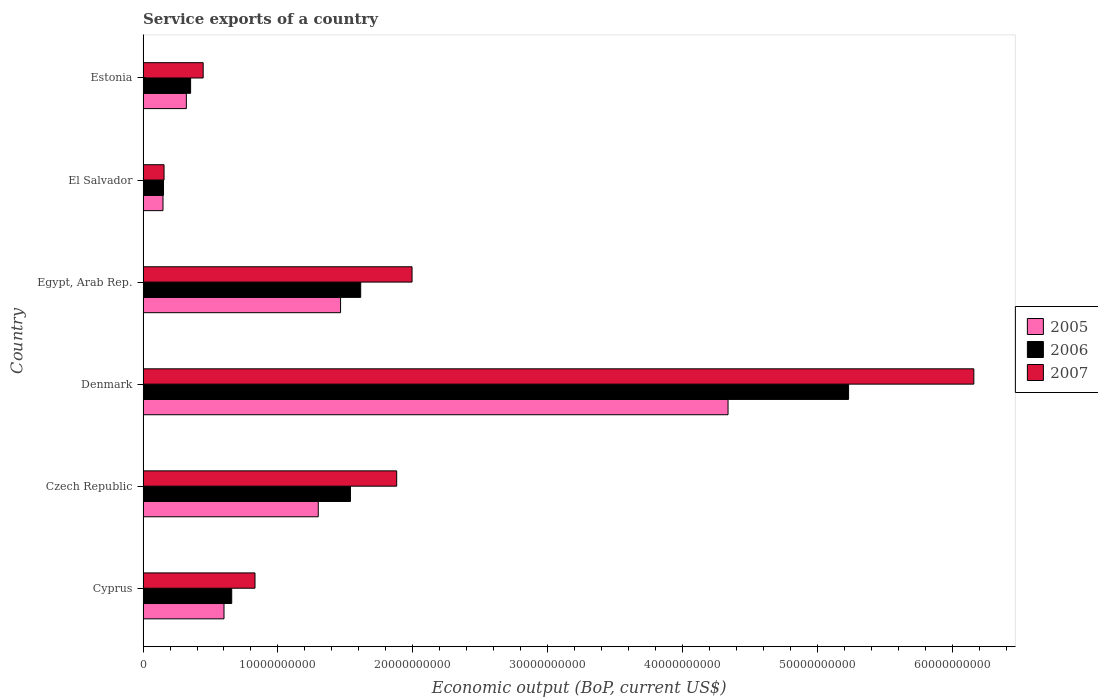Are the number of bars per tick equal to the number of legend labels?
Provide a succinct answer. Yes. Are the number of bars on each tick of the Y-axis equal?
Ensure brevity in your answer.  Yes. How many bars are there on the 5th tick from the top?
Offer a terse response. 3. In how many cases, is the number of bars for a given country not equal to the number of legend labels?
Give a very brief answer. 0. What is the service exports in 2006 in Czech Republic?
Your response must be concise. 1.54e+1. Across all countries, what is the maximum service exports in 2007?
Ensure brevity in your answer.  6.16e+1. Across all countries, what is the minimum service exports in 2005?
Your answer should be compact. 1.48e+09. In which country was the service exports in 2007 minimum?
Your response must be concise. El Salvador. What is the total service exports in 2006 in the graph?
Give a very brief answer. 9.54e+1. What is the difference between the service exports in 2007 in Czech Republic and that in El Salvador?
Your answer should be very brief. 1.72e+1. What is the difference between the service exports in 2007 in El Salvador and the service exports in 2006 in Czech Republic?
Provide a succinct answer. -1.38e+1. What is the average service exports in 2005 per country?
Give a very brief answer. 1.36e+1. What is the difference between the service exports in 2006 and service exports in 2007 in El Salvador?
Give a very brief answer. -3.97e+07. In how many countries, is the service exports in 2006 greater than 10000000000 US$?
Make the answer very short. 3. What is the ratio of the service exports in 2006 in Czech Republic to that in El Salvador?
Provide a succinct answer. 10.14. Is the service exports in 2007 in Cyprus less than that in Czech Republic?
Provide a short and direct response. Yes. Is the difference between the service exports in 2006 in Egypt, Arab Rep. and El Salvador greater than the difference between the service exports in 2007 in Egypt, Arab Rep. and El Salvador?
Provide a succinct answer. No. What is the difference between the highest and the second highest service exports in 2006?
Offer a very short reply. 3.62e+1. What is the difference between the highest and the lowest service exports in 2006?
Ensure brevity in your answer.  5.08e+1. In how many countries, is the service exports in 2005 greater than the average service exports in 2005 taken over all countries?
Your response must be concise. 2. Is the sum of the service exports in 2007 in Egypt, Arab Rep. and Estonia greater than the maximum service exports in 2005 across all countries?
Provide a succinct answer. No. What does the 3rd bar from the bottom in Denmark represents?
Offer a very short reply. 2007. Are all the bars in the graph horizontal?
Give a very brief answer. Yes. How many countries are there in the graph?
Offer a terse response. 6. Are the values on the major ticks of X-axis written in scientific E-notation?
Keep it short and to the point. No. Does the graph contain any zero values?
Provide a succinct answer. No. Does the graph contain grids?
Offer a terse response. No. How are the legend labels stacked?
Give a very brief answer. Vertical. What is the title of the graph?
Make the answer very short. Service exports of a country. Does "1998" appear as one of the legend labels in the graph?
Give a very brief answer. No. What is the label or title of the X-axis?
Your response must be concise. Economic output (BoP, current US$). What is the label or title of the Y-axis?
Your answer should be very brief. Country. What is the Economic output (BoP, current US$) of 2005 in Cyprus?
Ensure brevity in your answer.  6.00e+09. What is the Economic output (BoP, current US$) in 2006 in Cyprus?
Provide a short and direct response. 6.57e+09. What is the Economic output (BoP, current US$) of 2007 in Cyprus?
Provide a short and direct response. 8.30e+09. What is the Economic output (BoP, current US$) of 2005 in Czech Republic?
Keep it short and to the point. 1.30e+1. What is the Economic output (BoP, current US$) in 2006 in Czech Republic?
Your response must be concise. 1.54e+1. What is the Economic output (BoP, current US$) in 2007 in Czech Republic?
Your answer should be compact. 1.88e+1. What is the Economic output (BoP, current US$) of 2005 in Denmark?
Provide a succinct answer. 4.34e+1. What is the Economic output (BoP, current US$) of 2006 in Denmark?
Give a very brief answer. 5.23e+1. What is the Economic output (BoP, current US$) of 2007 in Denmark?
Your response must be concise. 6.16e+1. What is the Economic output (BoP, current US$) of 2005 in Egypt, Arab Rep.?
Offer a very short reply. 1.46e+1. What is the Economic output (BoP, current US$) in 2006 in Egypt, Arab Rep.?
Make the answer very short. 1.61e+1. What is the Economic output (BoP, current US$) in 2007 in Egypt, Arab Rep.?
Offer a very short reply. 1.99e+1. What is the Economic output (BoP, current US$) of 2005 in El Salvador?
Ensure brevity in your answer.  1.48e+09. What is the Economic output (BoP, current US$) of 2006 in El Salvador?
Make the answer very short. 1.52e+09. What is the Economic output (BoP, current US$) in 2007 in El Salvador?
Provide a short and direct response. 1.56e+09. What is the Economic output (BoP, current US$) in 2005 in Estonia?
Make the answer very short. 3.21e+09. What is the Economic output (BoP, current US$) of 2006 in Estonia?
Keep it short and to the point. 3.52e+09. What is the Economic output (BoP, current US$) in 2007 in Estonia?
Offer a terse response. 4.46e+09. Across all countries, what is the maximum Economic output (BoP, current US$) of 2005?
Offer a terse response. 4.34e+1. Across all countries, what is the maximum Economic output (BoP, current US$) of 2006?
Give a very brief answer. 5.23e+1. Across all countries, what is the maximum Economic output (BoP, current US$) of 2007?
Provide a short and direct response. 6.16e+1. Across all countries, what is the minimum Economic output (BoP, current US$) in 2005?
Make the answer very short. 1.48e+09. Across all countries, what is the minimum Economic output (BoP, current US$) of 2006?
Ensure brevity in your answer.  1.52e+09. Across all countries, what is the minimum Economic output (BoP, current US$) in 2007?
Your response must be concise. 1.56e+09. What is the total Economic output (BoP, current US$) of 2005 in the graph?
Your answer should be very brief. 8.17e+1. What is the total Economic output (BoP, current US$) of 2006 in the graph?
Provide a succinct answer. 9.54e+1. What is the total Economic output (BoP, current US$) of 2007 in the graph?
Your answer should be very brief. 1.15e+11. What is the difference between the Economic output (BoP, current US$) in 2005 in Cyprus and that in Czech Republic?
Your answer should be very brief. -6.99e+09. What is the difference between the Economic output (BoP, current US$) of 2006 in Cyprus and that in Czech Republic?
Make the answer very short. -8.80e+09. What is the difference between the Economic output (BoP, current US$) in 2007 in Cyprus and that in Czech Republic?
Provide a succinct answer. -1.05e+1. What is the difference between the Economic output (BoP, current US$) of 2005 in Cyprus and that in Denmark?
Give a very brief answer. -3.74e+1. What is the difference between the Economic output (BoP, current US$) of 2006 in Cyprus and that in Denmark?
Provide a short and direct response. -4.57e+1. What is the difference between the Economic output (BoP, current US$) in 2007 in Cyprus and that in Denmark?
Provide a succinct answer. -5.33e+1. What is the difference between the Economic output (BoP, current US$) of 2005 in Cyprus and that in Egypt, Arab Rep.?
Your answer should be very brief. -8.64e+09. What is the difference between the Economic output (BoP, current US$) of 2006 in Cyprus and that in Egypt, Arab Rep.?
Your response must be concise. -9.56e+09. What is the difference between the Economic output (BoP, current US$) in 2007 in Cyprus and that in Egypt, Arab Rep.?
Your answer should be very brief. -1.16e+1. What is the difference between the Economic output (BoP, current US$) in 2005 in Cyprus and that in El Salvador?
Keep it short and to the point. 4.52e+09. What is the difference between the Economic output (BoP, current US$) of 2006 in Cyprus and that in El Salvador?
Ensure brevity in your answer.  5.06e+09. What is the difference between the Economic output (BoP, current US$) in 2007 in Cyprus and that in El Salvador?
Give a very brief answer. 6.74e+09. What is the difference between the Economic output (BoP, current US$) in 2005 in Cyprus and that in Estonia?
Make the answer very short. 2.79e+09. What is the difference between the Economic output (BoP, current US$) in 2006 in Cyprus and that in Estonia?
Offer a very short reply. 3.05e+09. What is the difference between the Economic output (BoP, current US$) in 2007 in Cyprus and that in Estonia?
Ensure brevity in your answer.  3.84e+09. What is the difference between the Economic output (BoP, current US$) of 2005 in Czech Republic and that in Denmark?
Make the answer very short. -3.04e+1. What is the difference between the Economic output (BoP, current US$) of 2006 in Czech Republic and that in Denmark?
Your answer should be compact. -3.69e+1. What is the difference between the Economic output (BoP, current US$) in 2007 in Czech Republic and that in Denmark?
Ensure brevity in your answer.  -4.28e+1. What is the difference between the Economic output (BoP, current US$) in 2005 in Czech Republic and that in Egypt, Arab Rep.?
Keep it short and to the point. -1.65e+09. What is the difference between the Economic output (BoP, current US$) of 2006 in Czech Republic and that in Egypt, Arab Rep.?
Make the answer very short. -7.59e+08. What is the difference between the Economic output (BoP, current US$) of 2007 in Czech Republic and that in Egypt, Arab Rep.?
Provide a short and direct response. -1.14e+09. What is the difference between the Economic output (BoP, current US$) of 2005 in Czech Republic and that in El Salvador?
Provide a succinct answer. 1.15e+1. What is the difference between the Economic output (BoP, current US$) of 2006 in Czech Republic and that in El Salvador?
Give a very brief answer. 1.39e+1. What is the difference between the Economic output (BoP, current US$) of 2007 in Czech Republic and that in El Salvador?
Provide a short and direct response. 1.72e+1. What is the difference between the Economic output (BoP, current US$) of 2005 in Czech Republic and that in Estonia?
Provide a succinct answer. 9.78e+09. What is the difference between the Economic output (BoP, current US$) of 2006 in Czech Republic and that in Estonia?
Your answer should be very brief. 1.19e+1. What is the difference between the Economic output (BoP, current US$) of 2007 in Czech Republic and that in Estonia?
Make the answer very short. 1.43e+1. What is the difference between the Economic output (BoP, current US$) in 2005 in Denmark and that in Egypt, Arab Rep.?
Provide a succinct answer. 2.87e+1. What is the difference between the Economic output (BoP, current US$) in 2006 in Denmark and that in Egypt, Arab Rep.?
Ensure brevity in your answer.  3.62e+1. What is the difference between the Economic output (BoP, current US$) of 2007 in Denmark and that in Egypt, Arab Rep.?
Make the answer very short. 4.17e+1. What is the difference between the Economic output (BoP, current US$) in 2005 in Denmark and that in El Salvador?
Offer a terse response. 4.19e+1. What is the difference between the Economic output (BoP, current US$) in 2006 in Denmark and that in El Salvador?
Your answer should be very brief. 5.08e+1. What is the difference between the Economic output (BoP, current US$) in 2007 in Denmark and that in El Salvador?
Give a very brief answer. 6.00e+1. What is the difference between the Economic output (BoP, current US$) in 2005 in Denmark and that in Estonia?
Make the answer very short. 4.02e+1. What is the difference between the Economic output (BoP, current US$) of 2006 in Denmark and that in Estonia?
Offer a terse response. 4.88e+1. What is the difference between the Economic output (BoP, current US$) of 2007 in Denmark and that in Estonia?
Offer a terse response. 5.71e+1. What is the difference between the Economic output (BoP, current US$) in 2005 in Egypt, Arab Rep. and that in El Salvador?
Offer a terse response. 1.32e+1. What is the difference between the Economic output (BoP, current US$) in 2006 in Egypt, Arab Rep. and that in El Salvador?
Your response must be concise. 1.46e+1. What is the difference between the Economic output (BoP, current US$) in 2007 in Egypt, Arab Rep. and that in El Salvador?
Your response must be concise. 1.84e+1. What is the difference between the Economic output (BoP, current US$) of 2005 in Egypt, Arab Rep. and that in Estonia?
Give a very brief answer. 1.14e+1. What is the difference between the Economic output (BoP, current US$) in 2006 in Egypt, Arab Rep. and that in Estonia?
Keep it short and to the point. 1.26e+1. What is the difference between the Economic output (BoP, current US$) in 2007 in Egypt, Arab Rep. and that in Estonia?
Your response must be concise. 1.55e+1. What is the difference between the Economic output (BoP, current US$) in 2005 in El Salvador and that in Estonia?
Offer a very short reply. -1.73e+09. What is the difference between the Economic output (BoP, current US$) in 2006 in El Salvador and that in Estonia?
Provide a succinct answer. -2.01e+09. What is the difference between the Economic output (BoP, current US$) of 2007 in El Salvador and that in Estonia?
Ensure brevity in your answer.  -2.90e+09. What is the difference between the Economic output (BoP, current US$) in 2005 in Cyprus and the Economic output (BoP, current US$) in 2006 in Czech Republic?
Your answer should be very brief. -9.37e+09. What is the difference between the Economic output (BoP, current US$) in 2005 in Cyprus and the Economic output (BoP, current US$) in 2007 in Czech Republic?
Ensure brevity in your answer.  -1.28e+1. What is the difference between the Economic output (BoP, current US$) of 2006 in Cyprus and the Economic output (BoP, current US$) of 2007 in Czech Republic?
Ensure brevity in your answer.  -1.22e+1. What is the difference between the Economic output (BoP, current US$) of 2005 in Cyprus and the Economic output (BoP, current US$) of 2006 in Denmark?
Your response must be concise. -4.63e+1. What is the difference between the Economic output (BoP, current US$) of 2005 in Cyprus and the Economic output (BoP, current US$) of 2007 in Denmark?
Your answer should be compact. -5.56e+1. What is the difference between the Economic output (BoP, current US$) in 2006 in Cyprus and the Economic output (BoP, current US$) in 2007 in Denmark?
Offer a terse response. -5.50e+1. What is the difference between the Economic output (BoP, current US$) of 2005 in Cyprus and the Economic output (BoP, current US$) of 2006 in Egypt, Arab Rep.?
Keep it short and to the point. -1.01e+1. What is the difference between the Economic output (BoP, current US$) in 2005 in Cyprus and the Economic output (BoP, current US$) in 2007 in Egypt, Arab Rep.?
Make the answer very short. -1.39e+1. What is the difference between the Economic output (BoP, current US$) of 2006 in Cyprus and the Economic output (BoP, current US$) of 2007 in Egypt, Arab Rep.?
Provide a short and direct response. -1.34e+1. What is the difference between the Economic output (BoP, current US$) in 2005 in Cyprus and the Economic output (BoP, current US$) in 2006 in El Salvador?
Provide a succinct answer. 4.49e+09. What is the difference between the Economic output (BoP, current US$) of 2005 in Cyprus and the Economic output (BoP, current US$) of 2007 in El Salvador?
Your answer should be very brief. 4.45e+09. What is the difference between the Economic output (BoP, current US$) of 2006 in Cyprus and the Economic output (BoP, current US$) of 2007 in El Salvador?
Your answer should be compact. 5.02e+09. What is the difference between the Economic output (BoP, current US$) in 2005 in Cyprus and the Economic output (BoP, current US$) in 2006 in Estonia?
Provide a short and direct response. 2.48e+09. What is the difference between the Economic output (BoP, current US$) in 2005 in Cyprus and the Economic output (BoP, current US$) in 2007 in Estonia?
Offer a very short reply. 1.54e+09. What is the difference between the Economic output (BoP, current US$) in 2006 in Cyprus and the Economic output (BoP, current US$) in 2007 in Estonia?
Offer a terse response. 2.12e+09. What is the difference between the Economic output (BoP, current US$) of 2005 in Czech Republic and the Economic output (BoP, current US$) of 2006 in Denmark?
Offer a very short reply. -3.93e+1. What is the difference between the Economic output (BoP, current US$) in 2005 in Czech Republic and the Economic output (BoP, current US$) in 2007 in Denmark?
Provide a short and direct response. -4.86e+1. What is the difference between the Economic output (BoP, current US$) in 2006 in Czech Republic and the Economic output (BoP, current US$) in 2007 in Denmark?
Offer a very short reply. -4.62e+1. What is the difference between the Economic output (BoP, current US$) in 2005 in Czech Republic and the Economic output (BoP, current US$) in 2006 in Egypt, Arab Rep.?
Your answer should be compact. -3.14e+09. What is the difference between the Economic output (BoP, current US$) of 2005 in Czech Republic and the Economic output (BoP, current US$) of 2007 in Egypt, Arab Rep.?
Ensure brevity in your answer.  -6.95e+09. What is the difference between the Economic output (BoP, current US$) of 2006 in Czech Republic and the Economic output (BoP, current US$) of 2007 in Egypt, Arab Rep.?
Your answer should be very brief. -4.57e+09. What is the difference between the Economic output (BoP, current US$) in 2005 in Czech Republic and the Economic output (BoP, current US$) in 2006 in El Salvador?
Give a very brief answer. 1.15e+1. What is the difference between the Economic output (BoP, current US$) of 2005 in Czech Republic and the Economic output (BoP, current US$) of 2007 in El Salvador?
Keep it short and to the point. 1.14e+1. What is the difference between the Economic output (BoP, current US$) in 2006 in Czech Republic and the Economic output (BoP, current US$) in 2007 in El Salvador?
Keep it short and to the point. 1.38e+1. What is the difference between the Economic output (BoP, current US$) of 2005 in Czech Republic and the Economic output (BoP, current US$) of 2006 in Estonia?
Your answer should be compact. 9.46e+09. What is the difference between the Economic output (BoP, current US$) of 2005 in Czech Republic and the Economic output (BoP, current US$) of 2007 in Estonia?
Offer a terse response. 8.53e+09. What is the difference between the Economic output (BoP, current US$) of 2006 in Czech Republic and the Economic output (BoP, current US$) of 2007 in Estonia?
Ensure brevity in your answer.  1.09e+1. What is the difference between the Economic output (BoP, current US$) in 2005 in Denmark and the Economic output (BoP, current US$) in 2006 in Egypt, Arab Rep.?
Ensure brevity in your answer.  2.72e+1. What is the difference between the Economic output (BoP, current US$) in 2005 in Denmark and the Economic output (BoP, current US$) in 2007 in Egypt, Arab Rep.?
Offer a very short reply. 2.34e+1. What is the difference between the Economic output (BoP, current US$) in 2006 in Denmark and the Economic output (BoP, current US$) in 2007 in Egypt, Arab Rep.?
Make the answer very short. 3.24e+1. What is the difference between the Economic output (BoP, current US$) in 2005 in Denmark and the Economic output (BoP, current US$) in 2006 in El Salvador?
Make the answer very short. 4.19e+1. What is the difference between the Economic output (BoP, current US$) in 2005 in Denmark and the Economic output (BoP, current US$) in 2007 in El Salvador?
Your answer should be very brief. 4.18e+1. What is the difference between the Economic output (BoP, current US$) in 2006 in Denmark and the Economic output (BoP, current US$) in 2007 in El Salvador?
Ensure brevity in your answer.  5.08e+1. What is the difference between the Economic output (BoP, current US$) of 2005 in Denmark and the Economic output (BoP, current US$) of 2006 in Estonia?
Provide a succinct answer. 3.98e+1. What is the difference between the Economic output (BoP, current US$) of 2005 in Denmark and the Economic output (BoP, current US$) of 2007 in Estonia?
Make the answer very short. 3.89e+1. What is the difference between the Economic output (BoP, current US$) in 2006 in Denmark and the Economic output (BoP, current US$) in 2007 in Estonia?
Your response must be concise. 4.79e+1. What is the difference between the Economic output (BoP, current US$) in 2005 in Egypt, Arab Rep. and the Economic output (BoP, current US$) in 2006 in El Salvador?
Ensure brevity in your answer.  1.31e+1. What is the difference between the Economic output (BoP, current US$) in 2005 in Egypt, Arab Rep. and the Economic output (BoP, current US$) in 2007 in El Salvador?
Ensure brevity in your answer.  1.31e+1. What is the difference between the Economic output (BoP, current US$) in 2006 in Egypt, Arab Rep. and the Economic output (BoP, current US$) in 2007 in El Salvador?
Your response must be concise. 1.46e+1. What is the difference between the Economic output (BoP, current US$) of 2005 in Egypt, Arab Rep. and the Economic output (BoP, current US$) of 2006 in Estonia?
Make the answer very short. 1.11e+1. What is the difference between the Economic output (BoP, current US$) in 2005 in Egypt, Arab Rep. and the Economic output (BoP, current US$) in 2007 in Estonia?
Ensure brevity in your answer.  1.02e+1. What is the difference between the Economic output (BoP, current US$) of 2006 in Egypt, Arab Rep. and the Economic output (BoP, current US$) of 2007 in Estonia?
Offer a very short reply. 1.17e+1. What is the difference between the Economic output (BoP, current US$) of 2005 in El Salvador and the Economic output (BoP, current US$) of 2006 in Estonia?
Ensure brevity in your answer.  -2.05e+09. What is the difference between the Economic output (BoP, current US$) in 2005 in El Salvador and the Economic output (BoP, current US$) in 2007 in Estonia?
Offer a terse response. -2.98e+09. What is the difference between the Economic output (BoP, current US$) in 2006 in El Salvador and the Economic output (BoP, current US$) in 2007 in Estonia?
Keep it short and to the point. -2.94e+09. What is the average Economic output (BoP, current US$) in 2005 per country?
Offer a very short reply. 1.36e+1. What is the average Economic output (BoP, current US$) in 2006 per country?
Provide a succinct answer. 1.59e+1. What is the average Economic output (BoP, current US$) of 2007 per country?
Offer a terse response. 1.91e+1. What is the difference between the Economic output (BoP, current US$) of 2005 and Economic output (BoP, current US$) of 2006 in Cyprus?
Offer a very short reply. -5.72e+08. What is the difference between the Economic output (BoP, current US$) in 2005 and Economic output (BoP, current US$) in 2007 in Cyprus?
Provide a short and direct response. -2.30e+09. What is the difference between the Economic output (BoP, current US$) in 2006 and Economic output (BoP, current US$) in 2007 in Cyprus?
Your answer should be compact. -1.73e+09. What is the difference between the Economic output (BoP, current US$) of 2005 and Economic output (BoP, current US$) of 2006 in Czech Republic?
Your answer should be compact. -2.39e+09. What is the difference between the Economic output (BoP, current US$) of 2005 and Economic output (BoP, current US$) of 2007 in Czech Republic?
Keep it short and to the point. -5.82e+09. What is the difference between the Economic output (BoP, current US$) of 2006 and Economic output (BoP, current US$) of 2007 in Czech Republic?
Your answer should be very brief. -3.43e+09. What is the difference between the Economic output (BoP, current US$) in 2005 and Economic output (BoP, current US$) in 2006 in Denmark?
Make the answer very short. -8.94e+09. What is the difference between the Economic output (BoP, current US$) in 2005 and Economic output (BoP, current US$) in 2007 in Denmark?
Offer a terse response. -1.82e+1. What is the difference between the Economic output (BoP, current US$) in 2006 and Economic output (BoP, current US$) in 2007 in Denmark?
Your answer should be very brief. -9.29e+09. What is the difference between the Economic output (BoP, current US$) of 2005 and Economic output (BoP, current US$) of 2006 in Egypt, Arab Rep.?
Ensure brevity in your answer.  -1.49e+09. What is the difference between the Economic output (BoP, current US$) of 2005 and Economic output (BoP, current US$) of 2007 in Egypt, Arab Rep.?
Give a very brief answer. -5.30e+09. What is the difference between the Economic output (BoP, current US$) in 2006 and Economic output (BoP, current US$) in 2007 in Egypt, Arab Rep.?
Give a very brief answer. -3.81e+09. What is the difference between the Economic output (BoP, current US$) in 2005 and Economic output (BoP, current US$) in 2006 in El Salvador?
Your response must be concise. -3.79e+07. What is the difference between the Economic output (BoP, current US$) in 2005 and Economic output (BoP, current US$) in 2007 in El Salvador?
Offer a very short reply. -7.76e+07. What is the difference between the Economic output (BoP, current US$) in 2006 and Economic output (BoP, current US$) in 2007 in El Salvador?
Make the answer very short. -3.97e+07. What is the difference between the Economic output (BoP, current US$) of 2005 and Economic output (BoP, current US$) of 2006 in Estonia?
Provide a short and direct response. -3.15e+08. What is the difference between the Economic output (BoP, current US$) of 2005 and Economic output (BoP, current US$) of 2007 in Estonia?
Your answer should be very brief. -1.25e+09. What is the difference between the Economic output (BoP, current US$) of 2006 and Economic output (BoP, current US$) of 2007 in Estonia?
Offer a terse response. -9.32e+08. What is the ratio of the Economic output (BoP, current US$) in 2005 in Cyprus to that in Czech Republic?
Your answer should be compact. 0.46. What is the ratio of the Economic output (BoP, current US$) in 2006 in Cyprus to that in Czech Republic?
Make the answer very short. 0.43. What is the ratio of the Economic output (BoP, current US$) of 2007 in Cyprus to that in Czech Republic?
Your response must be concise. 0.44. What is the ratio of the Economic output (BoP, current US$) of 2005 in Cyprus to that in Denmark?
Your answer should be very brief. 0.14. What is the ratio of the Economic output (BoP, current US$) of 2006 in Cyprus to that in Denmark?
Your answer should be compact. 0.13. What is the ratio of the Economic output (BoP, current US$) in 2007 in Cyprus to that in Denmark?
Your response must be concise. 0.13. What is the ratio of the Economic output (BoP, current US$) in 2005 in Cyprus to that in Egypt, Arab Rep.?
Offer a terse response. 0.41. What is the ratio of the Economic output (BoP, current US$) in 2006 in Cyprus to that in Egypt, Arab Rep.?
Offer a very short reply. 0.41. What is the ratio of the Economic output (BoP, current US$) of 2007 in Cyprus to that in Egypt, Arab Rep.?
Offer a terse response. 0.42. What is the ratio of the Economic output (BoP, current US$) of 2005 in Cyprus to that in El Salvador?
Provide a succinct answer. 4.06. What is the ratio of the Economic output (BoP, current US$) of 2006 in Cyprus to that in El Salvador?
Your answer should be compact. 4.34. What is the ratio of the Economic output (BoP, current US$) in 2007 in Cyprus to that in El Salvador?
Offer a very short reply. 5.34. What is the ratio of the Economic output (BoP, current US$) of 2005 in Cyprus to that in Estonia?
Your answer should be very brief. 1.87. What is the ratio of the Economic output (BoP, current US$) of 2006 in Cyprus to that in Estonia?
Keep it short and to the point. 1.86. What is the ratio of the Economic output (BoP, current US$) in 2007 in Cyprus to that in Estonia?
Give a very brief answer. 1.86. What is the ratio of the Economic output (BoP, current US$) of 2005 in Czech Republic to that in Denmark?
Your answer should be very brief. 0.3. What is the ratio of the Economic output (BoP, current US$) in 2006 in Czech Republic to that in Denmark?
Make the answer very short. 0.29. What is the ratio of the Economic output (BoP, current US$) in 2007 in Czech Republic to that in Denmark?
Make the answer very short. 0.31. What is the ratio of the Economic output (BoP, current US$) in 2005 in Czech Republic to that in Egypt, Arab Rep.?
Keep it short and to the point. 0.89. What is the ratio of the Economic output (BoP, current US$) in 2006 in Czech Republic to that in Egypt, Arab Rep.?
Keep it short and to the point. 0.95. What is the ratio of the Economic output (BoP, current US$) in 2007 in Czech Republic to that in Egypt, Arab Rep.?
Ensure brevity in your answer.  0.94. What is the ratio of the Economic output (BoP, current US$) of 2005 in Czech Republic to that in El Salvador?
Keep it short and to the point. 8.79. What is the ratio of the Economic output (BoP, current US$) in 2006 in Czech Republic to that in El Salvador?
Keep it short and to the point. 10.14. What is the ratio of the Economic output (BoP, current US$) in 2007 in Czech Republic to that in El Salvador?
Your response must be concise. 12.09. What is the ratio of the Economic output (BoP, current US$) in 2005 in Czech Republic to that in Estonia?
Offer a very short reply. 4.05. What is the ratio of the Economic output (BoP, current US$) in 2006 in Czech Republic to that in Estonia?
Offer a very short reply. 4.36. What is the ratio of the Economic output (BoP, current US$) in 2007 in Czech Republic to that in Estonia?
Offer a very short reply. 4.22. What is the ratio of the Economic output (BoP, current US$) of 2005 in Denmark to that in Egypt, Arab Rep.?
Make the answer very short. 2.96. What is the ratio of the Economic output (BoP, current US$) of 2006 in Denmark to that in Egypt, Arab Rep.?
Your answer should be compact. 3.24. What is the ratio of the Economic output (BoP, current US$) in 2007 in Denmark to that in Egypt, Arab Rep.?
Keep it short and to the point. 3.09. What is the ratio of the Economic output (BoP, current US$) of 2005 in Denmark to that in El Salvador?
Ensure brevity in your answer.  29.34. What is the ratio of the Economic output (BoP, current US$) of 2006 in Denmark to that in El Salvador?
Offer a terse response. 34.5. What is the ratio of the Economic output (BoP, current US$) in 2007 in Denmark to that in El Salvador?
Keep it short and to the point. 39.59. What is the ratio of the Economic output (BoP, current US$) of 2005 in Denmark to that in Estonia?
Provide a short and direct response. 13.51. What is the ratio of the Economic output (BoP, current US$) of 2006 in Denmark to that in Estonia?
Provide a succinct answer. 14.84. What is the ratio of the Economic output (BoP, current US$) in 2007 in Denmark to that in Estonia?
Provide a succinct answer. 13.82. What is the ratio of the Economic output (BoP, current US$) of 2005 in Egypt, Arab Rep. to that in El Salvador?
Offer a terse response. 9.91. What is the ratio of the Economic output (BoP, current US$) of 2006 in Egypt, Arab Rep. to that in El Salvador?
Offer a very short reply. 10.64. What is the ratio of the Economic output (BoP, current US$) in 2007 in Egypt, Arab Rep. to that in El Salvador?
Provide a short and direct response. 12.82. What is the ratio of the Economic output (BoP, current US$) of 2005 in Egypt, Arab Rep. to that in Estonia?
Provide a short and direct response. 4.56. What is the ratio of the Economic output (BoP, current US$) of 2006 in Egypt, Arab Rep. to that in Estonia?
Make the answer very short. 4.58. What is the ratio of the Economic output (BoP, current US$) in 2007 in Egypt, Arab Rep. to that in Estonia?
Your answer should be compact. 4.48. What is the ratio of the Economic output (BoP, current US$) of 2005 in El Salvador to that in Estonia?
Your answer should be very brief. 0.46. What is the ratio of the Economic output (BoP, current US$) in 2006 in El Salvador to that in Estonia?
Make the answer very short. 0.43. What is the ratio of the Economic output (BoP, current US$) in 2007 in El Salvador to that in Estonia?
Ensure brevity in your answer.  0.35. What is the difference between the highest and the second highest Economic output (BoP, current US$) of 2005?
Make the answer very short. 2.87e+1. What is the difference between the highest and the second highest Economic output (BoP, current US$) in 2006?
Make the answer very short. 3.62e+1. What is the difference between the highest and the second highest Economic output (BoP, current US$) of 2007?
Your answer should be very brief. 4.17e+1. What is the difference between the highest and the lowest Economic output (BoP, current US$) of 2005?
Provide a short and direct response. 4.19e+1. What is the difference between the highest and the lowest Economic output (BoP, current US$) of 2006?
Provide a short and direct response. 5.08e+1. What is the difference between the highest and the lowest Economic output (BoP, current US$) in 2007?
Give a very brief answer. 6.00e+1. 